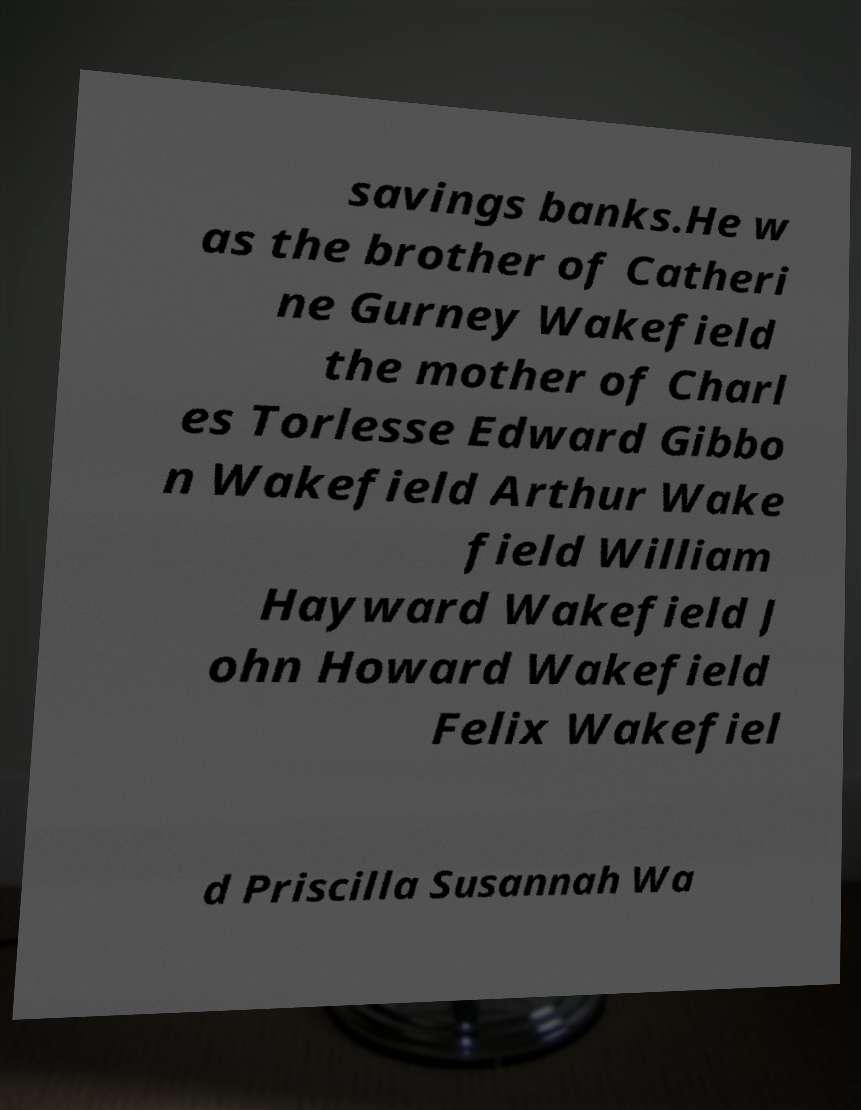Please read and relay the text visible in this image. What does it say? savings banks.He w as the brother of Catheri ne Gurney Wakefield the mother of Charl es Torlesse Edward Gibbo n Wakefield Arthur Wake field William Hayward Wakefield J ohn Howard Wakefield Felix Wakefiel d Priscilla Susannah Wa 